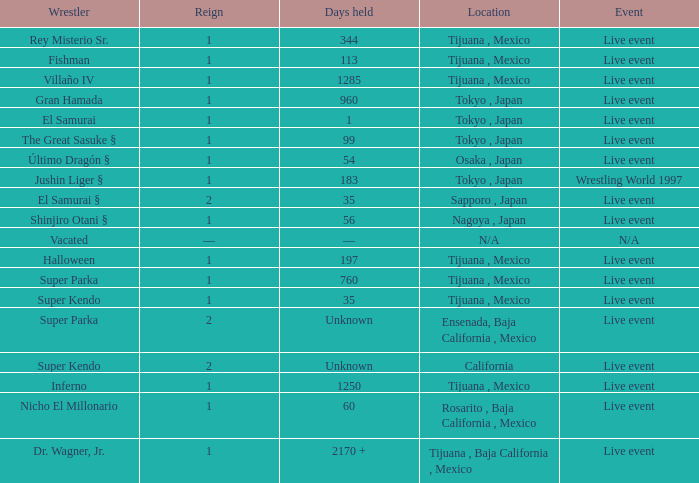In which event did the wrestler super parka secure a title with a reign of 2? Ensenada, Baja California , Mexico. 